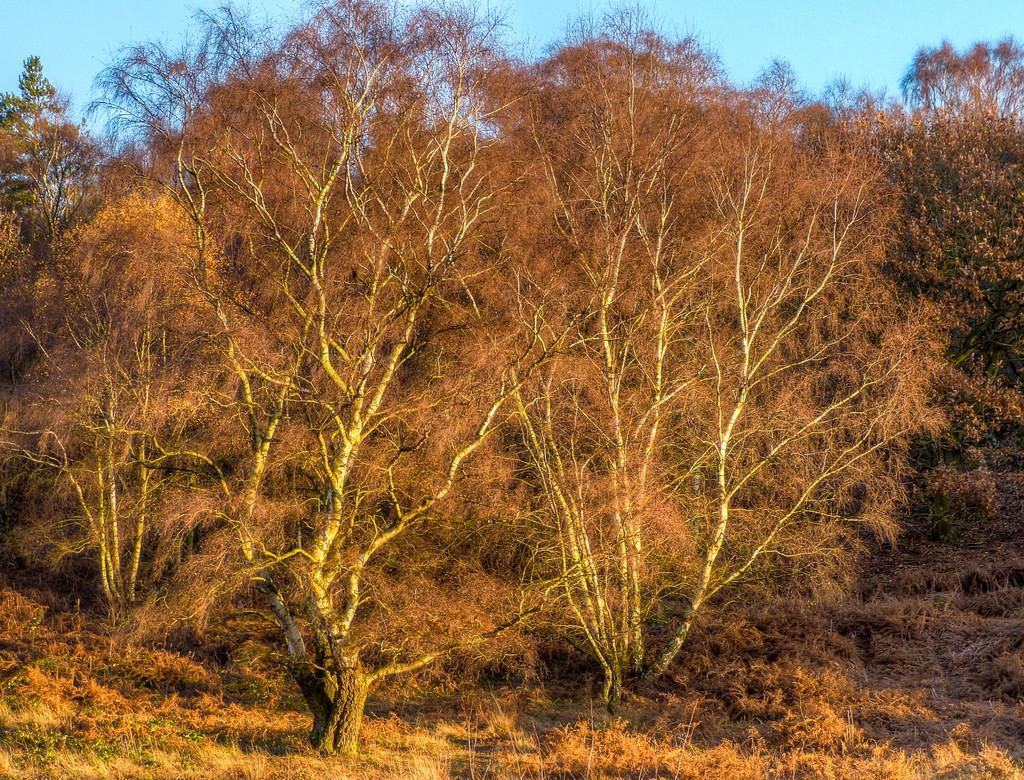What type of vegetation is present in the image? There are trees in the image. What is covering the ground in the image? There is grass on the ground in the image. What can be seen in the background of the image? The sky is visible in the background of the image. How many jellyfish can be seen swimming in the grass in the image? There are no jellyfish present in the image, and jellyfish cannot swim in grass. 